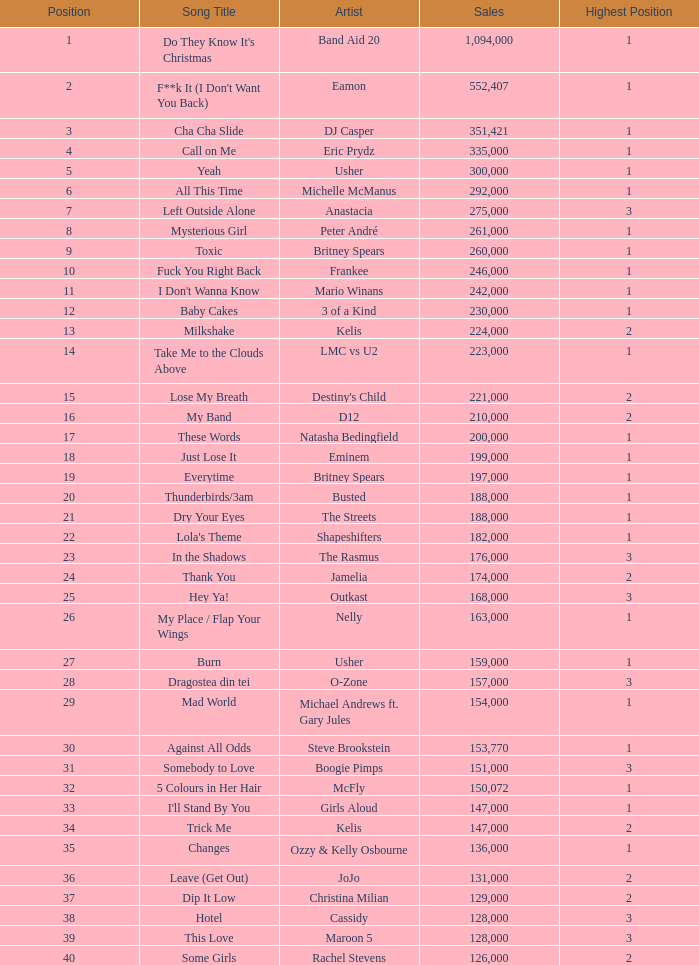What were the sales for Dj Casper when he was in a position lower than 13? 351421.0. 